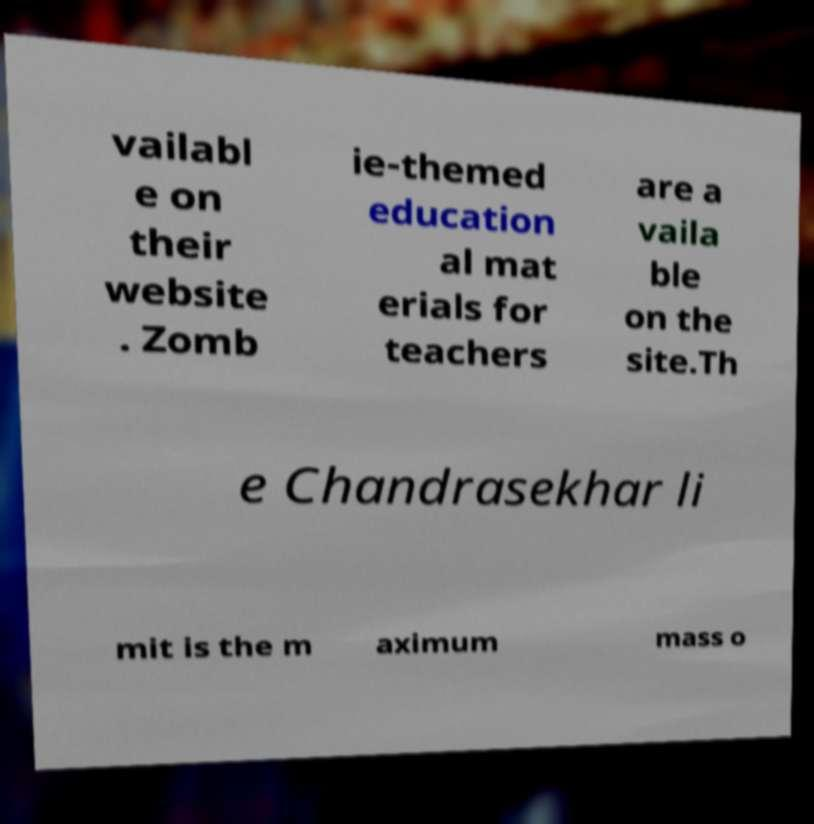There's text embedded in this image that I need extracted. Can you transcribe it verbatim? vailabl e on their website . Zomb ie-themed education al mat erials for teachers are a vaila ble on the site.Th e Chandrasekhar li mit is the m aximum mass o 